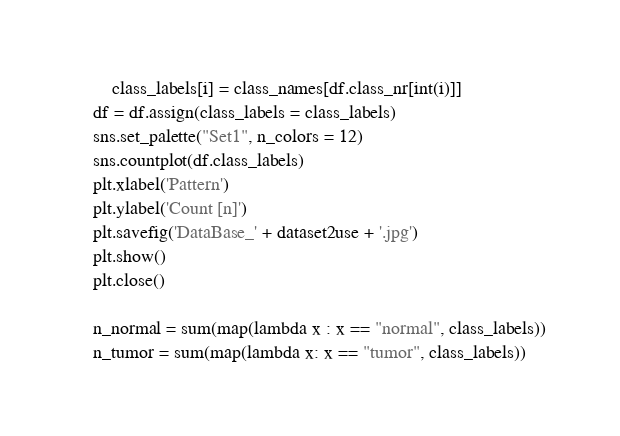Convert code to text. <code><loc_0><loc_0><loc_500><loc_500><_Python_>        class_labels[i] = class_names[df.class_nr[int(i)]]
    df = df.assign(class_labels = class_labels)
    sns.set_palette("Set1", n_colors = 12)
    sns.countplot(df.class_labels)
    plt.xlabel('Pattern')
    plt.ylabel('Count [n]')
    plt.savefig('DataBase_' + dataset2use + '.jpg')
    plt.show()
    plt.close()

    n_normal = sum(map(lambda x : x == "normal", class_labels))
    n_tumor = sum(map(lambda x: x == "tumor", class_labels))</code> 